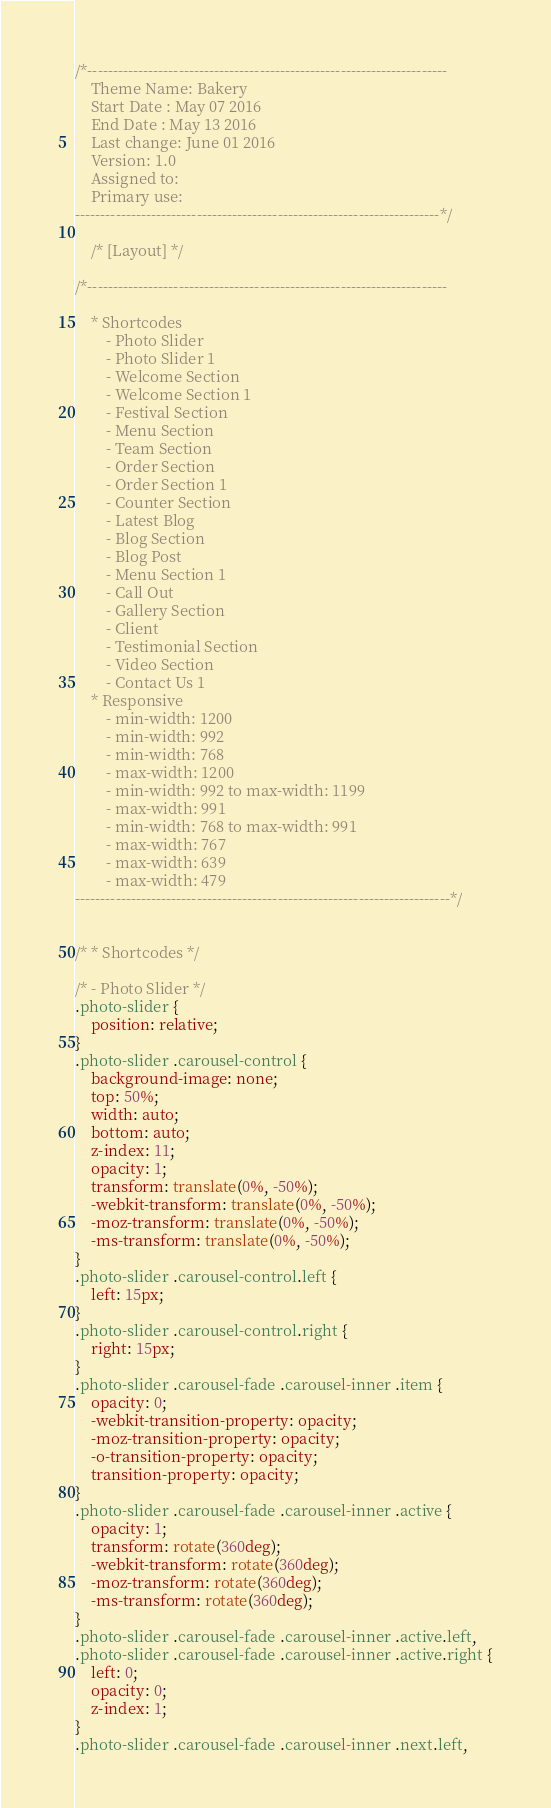Convert code to text. <code><loc_0><loc_0><loc_500><loc_500><_CSS_>/*-----------------------------------------------------------------------
	Theme Name: Bakery
	Start Date : May 07 2016
	End Date : May 13 2016
	Last change: June 01 2016
	Version: 1.0
	Assigned to:
	Primary use:
------------------------------------------------------------------------*/

	/* [Layout] */

/*-----------------------------------------------------------------------

	* Shortcodes
		- Photo Slider
		- Photo Slider 1
		- Welcome Section
		- Welcome Section 1
		- Festival Section
		- Menu Section
		- Team Section
		- Order Section
		- Order Section 1
		- Counter Section
		- Latest Blog
		- Blog Section
		- Blog Post
		- Menu Section 1
		- Call Out
		- Gallery Section
		- Client
		- Testimonial Section
		- Video Section
		- Contact Us 1
	* Responsive
		- min-width: 1200
		- min-width: 992
		- min-width: 768
		- max-width: 1200
		- min-width: 992 to max-width: 1199
		- max-width: 991
		- min-width: 768 to max-width: 991
		- max-width: 767
		- max-width: 639
		- max-width: 479
--------------------------------------------------------------------------*/


/* * Shortcodes */

/* - Photo Slider */
.photo-slider {
	position: relative;
}
.photo-slider .carousel-control {
    background-image: none;
	top: 50%;
	width: auto;
	bottom: auto;
	z-index: 11;
	opacity: 1;
	transform: translate(0%, -50%);
	-webkit-transform: translate(0%, -50%);
	-moz-transform: translate(0%, -50%);
	-ms-transform: translate(0%, -50%);
}
.photo-slider .carousel-control.left {
	left: 15px;
}
.photo-slider .carousel-control.right {
	right: 15px;
}
.photo-slider .carousel-fade .carousel-inner .item {
	opacity: 0;
	-webkit-transition-property: opacity;
	-moz-transition-property: opacity;
	-o-transition-property: opacity;
	transition-property: opacity;
}
.photo-slider .carousel-fade .carousel-inner .active {
	opacity: 1;
	transform: rotate(360deg);
	-webkit-transform: rotate(360deg);
	-moz-transform: rotate(360deg);
	-ms-transform: rotate(360deg);
}
.photo-slider .carousel-fade .carousel-inner .active.left,
.photo-slider .carousel-fade .carousel-inner .active.right {
	left: 0;
	opacity: 0;
	z-index: 1;
}
.photo-slider .carousel-fade .carousel-inner .next.left,</code> 